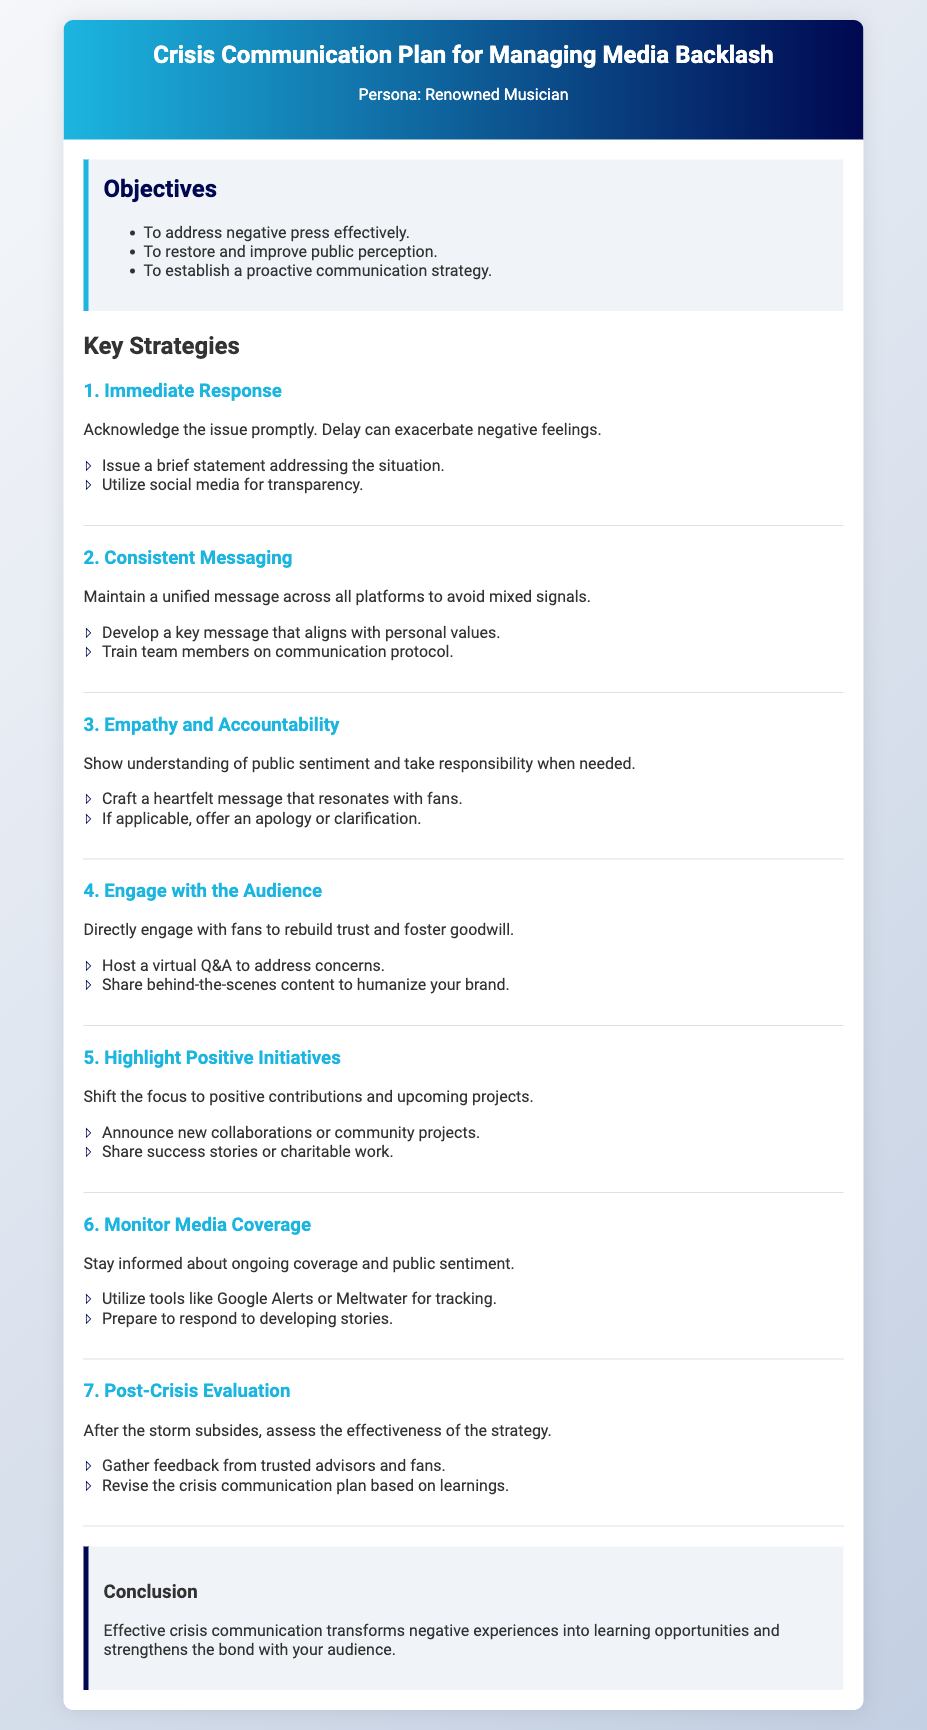What are the objectives of the crisis communication plan? The objectives are listed in the 'Objectives' section of the memo.
Answer: Address negative press effectively, restore and improve public perception, establish a proactive communication strategy What is the first key strategy mentioned? The first key strategy is specifically identified under 'Key Strategies'.
Answer: Immediate Response How many action items are listed under 'Engage with the Audience'? The number of action items can be counted in the corresponding section of the memo.
Answer: 2 What type of content should be shared to humanize the brand? This information is found in the 'Engage with the Audience' section.
Answer: Behind-the-scenes content What is the purpose of post-crisis evaluation? The purpose is stated in the 'Post-Crisis Evaluation' section of the memo.
Answer: Assess the effectiveness of the strategy Which strategy emphasizes empathy and accountability? The strategy that focuses on this aspect is listed under the 'Key Strategies' section.
Answer: Empathy and Accountability What should be prepared to respond to ongoing media coverage? This is mentioned in the 'Monitor Media Coverage' section.
Answer: Develop responses to developing stories 